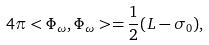Convert formula to latex. <formula><loc_0><loc_0><loc_500><loc_500>4 \pi < \Phi _ { \omega } , \Phi _ { \omega } > = \frac { 1 } { 2 } ( L - \sigma _ { 0 } ) ,</formula> 